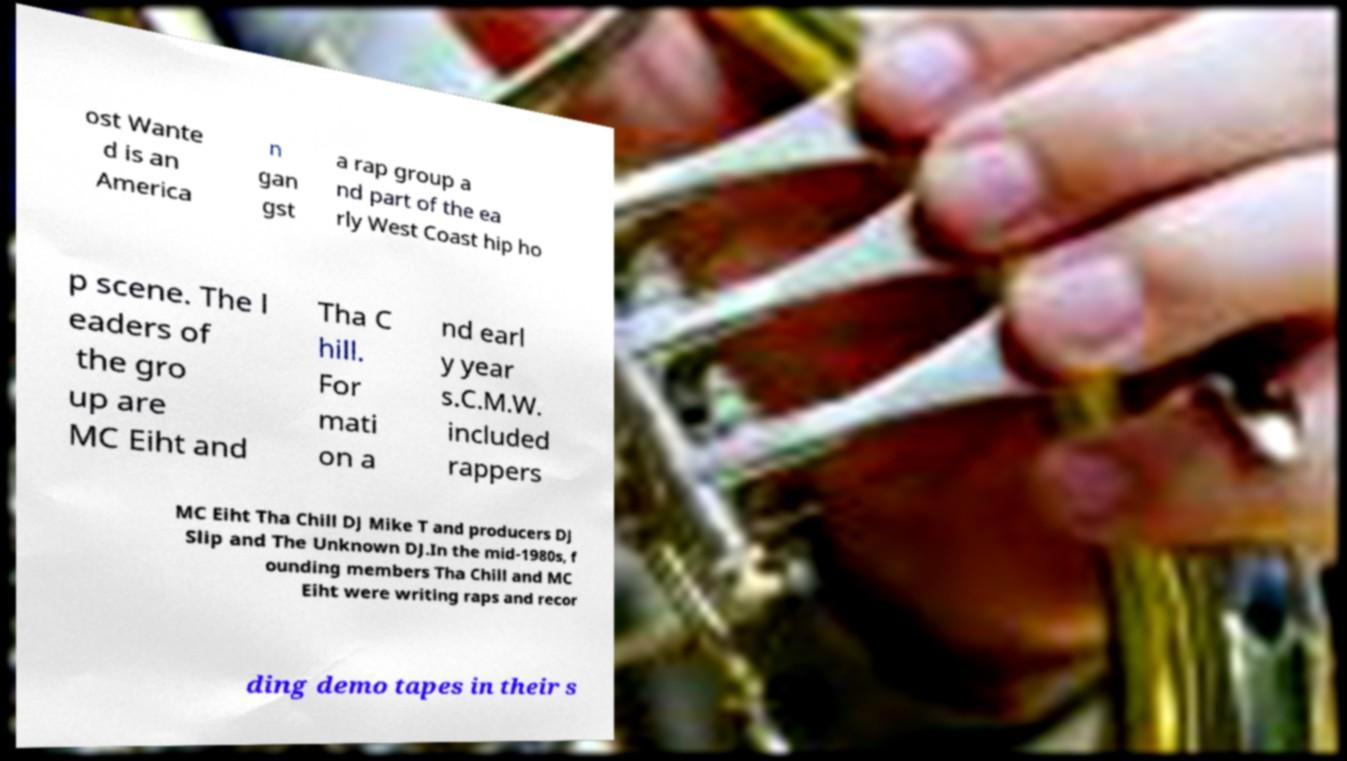For documentation purposes, I need the text within this image transcribed. Could you provide that? ost Wante d is an America n gan gst a rap group a nd part of the ea rly West Coast hip ho p scene. The l eaders of the gro up are MC Eiht and Tha C hill. For mati on a nd earl y year s.C.M.W. included rappers MC Eiht Tha Chill DJ Mike T and producers DJ Slip and The Unknown DJ.In the mid-1980s, f ounding members Tha Chill and MC Eiht were writing raps and recor ding demo tapes in their s 